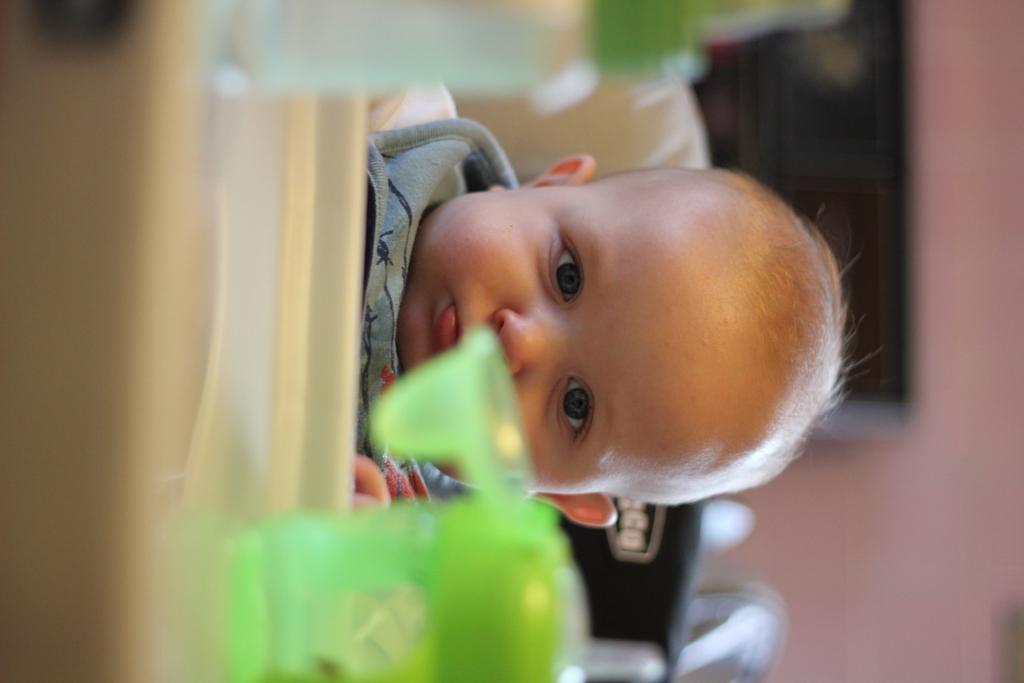Please provide a concise description of this image. In this image we can see a child and a bottle, in the background we can see the blur. 